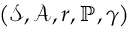<formula> <loc_0><loc_0><loc_500><loc_500>\left ( \mathcal { S , A } , r , \mathbb { P } , \gamma \right )</formula> 